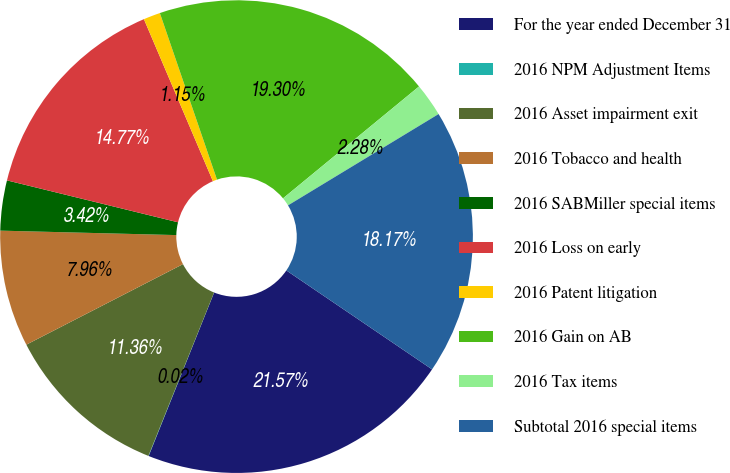<chart> <loc_0><loc_0><loc_500><loc_500><pie_chart><fcel>For the year ended December 31<fcel>2016 NPM Adjustment Items<fcel>2016 Asset impairment exit<fcel>2016 Tobacco and health<fcel>2016 SABMiller special items<fcel>2016 Loss on early<fcel>2016 Patent litigation<fcel>2016 Gain on AB<fcel>2016 Tax items<fcel>Subtotal 2016 special items<nl><fcel>21.57%<fcel>0.02%<fcel>11.36%<fcel>7.96%<fcel>3.42%<fcel>14.77%<fcel>1.15%<fcel>19.3%<fcel>2.28%<fcel>18.17%<nl></chart> 